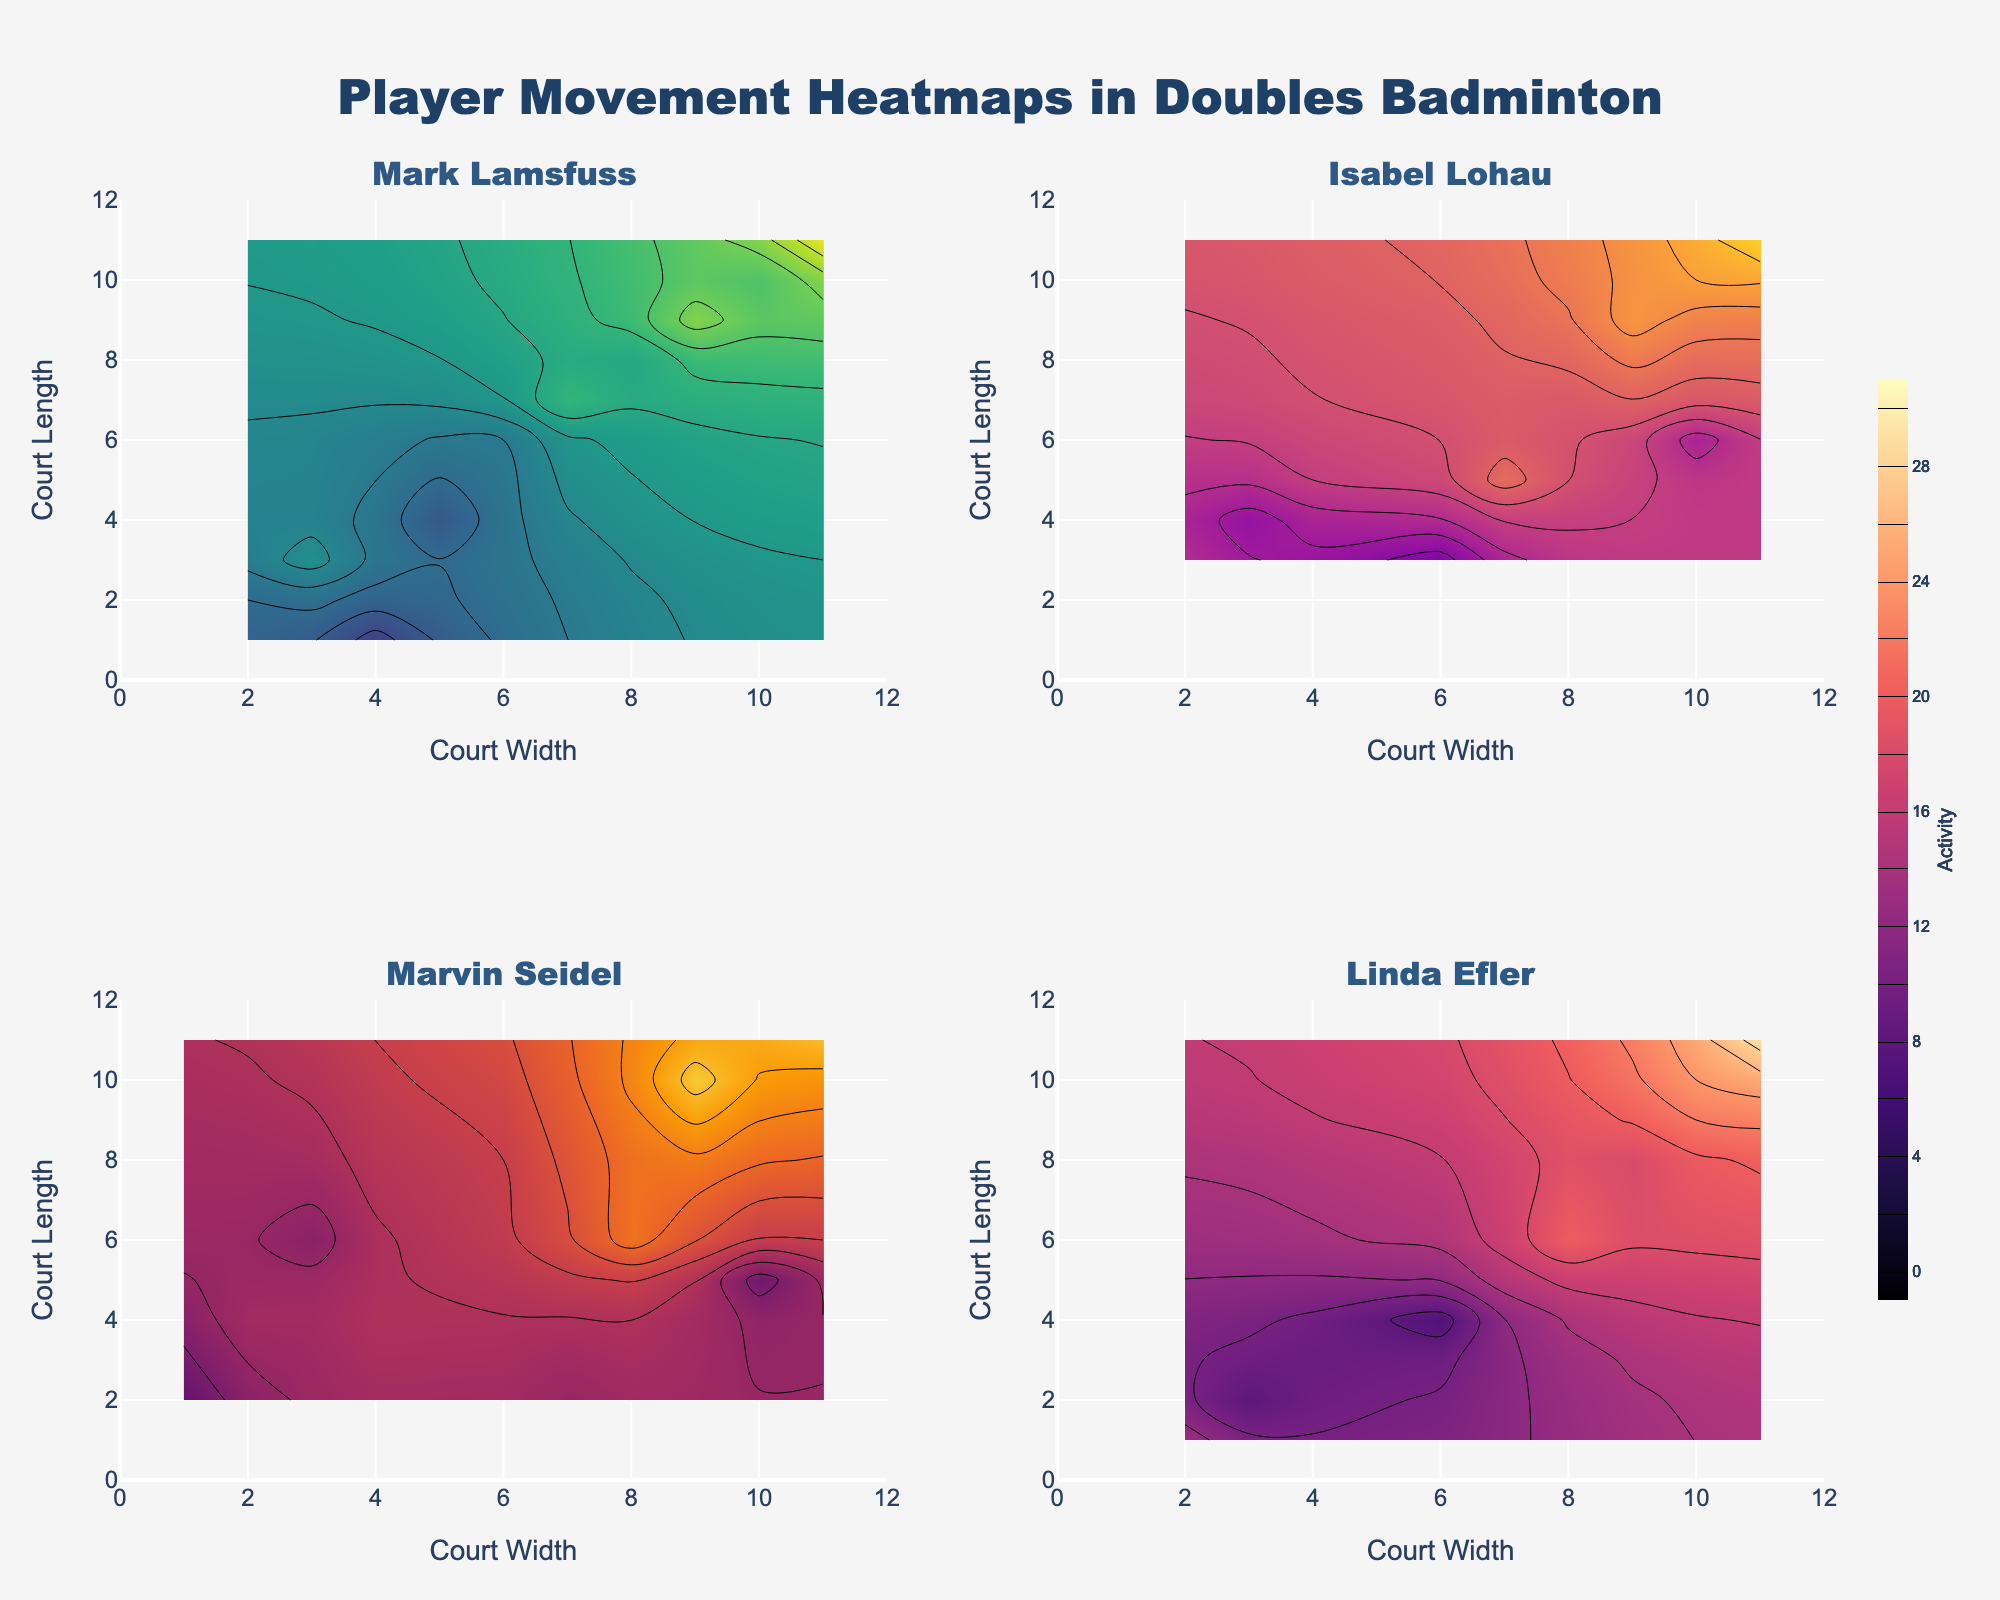What is the title of the figure? The title is displayed at the top of the figure. It reads "Player Movement Heatmaps in Doubles Badminton".
Answer: Player Movement Heatmaps in Doubles Badminton How many players are shown in the subplots? The subplot titles indicate the number of players. There are four subplot titles, each representing a different player.
Answer: Four Which player shows the highest activity around position (11, 11)? By inspecting the heatmaps, the region around (11, 11) has the highest activity for each player, but the numerical value on each color bar indicates that Mark Lamsfuss shows the highest activity count.
Answer: Mark Lamsfuss Why are the colorscales for each subplot different? The colorscales (Viridis, Plasma, Inferno, Magma) are used to differentiate between the player subplots visually, making it easier to distinguish their individual movements and activity levels.
Answer: To differentiate between the player subplots visually What is the range of the 'Court Width' axis for each subplot? The x-axis range is indicated on each subplot's x-axis, ranging from 0 to 12.
Answer: 0 to 12 Between Mark Lamsfuss and Isabel Lohau, who has higher activity at position (10, 10)? Checking the specific activity values in the respective subplots reveals that Isabel Lohau has a higher activity count at position (10, 10) compared to Mark Lamsfuss.
Answer: Isabel Lohau Which player has the most balanced distribution of movement across the court? By comparing the heatmaps' distribution, Linda Efler appears to have a more evenly spread activity across different positions, implying balanced movement.
Answer: Linda Efler What are the highest activity values observed for Marvin Seidel and where are they located? Inspecting Marvin Seidel's subplot, the highest activity value is 27, which is located at position (9, 10).
Answer: 27 at (9, 10) Compare the activity levels of Linda Efler and Marvin Seidel at position (11, 11). Who has higher activity? By looking at the contour values at position (11, 11), Linda Efler shows an activity of 29, while Marvin Seidel shows 26. Thus, Linda Efler has higher activity.
Answer: Linda Efler 